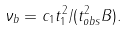<formula> <loc_0><loc_0><loc_500><loc_500>\nu _ { b } = c _ { 1 } t _ { 1 } ^ { 2 } / ( t _ { o b s } ^ { 2 } B ) .</formula> 